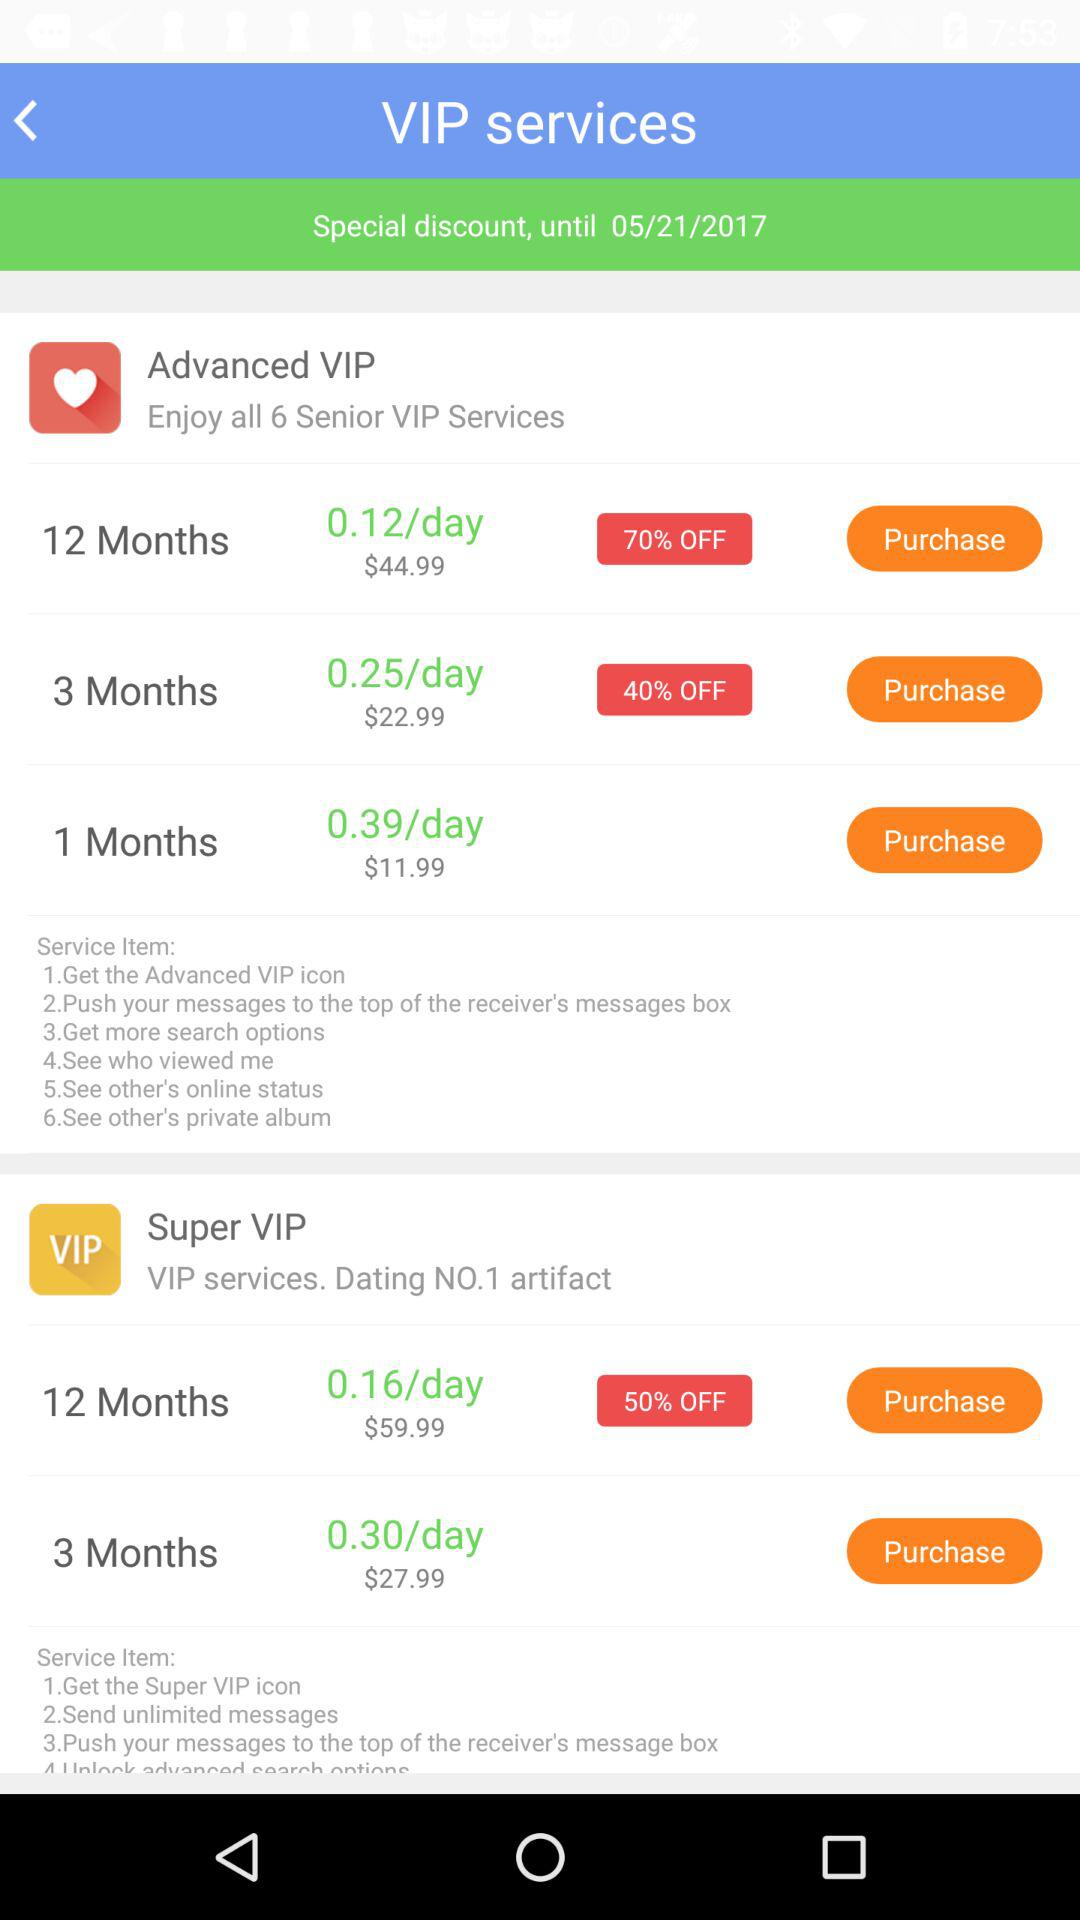What is the discount applicable for the Advance VIP three-month service? The discount applicable for the Advance VIP three-month service is 40%. 